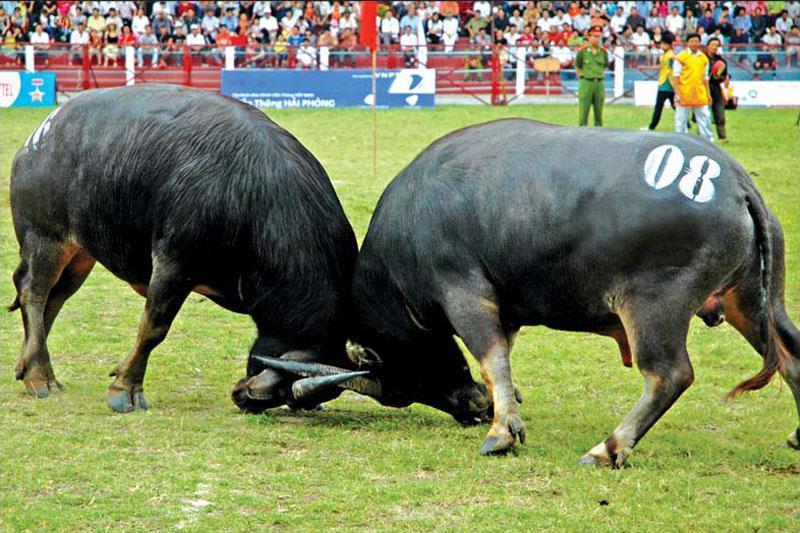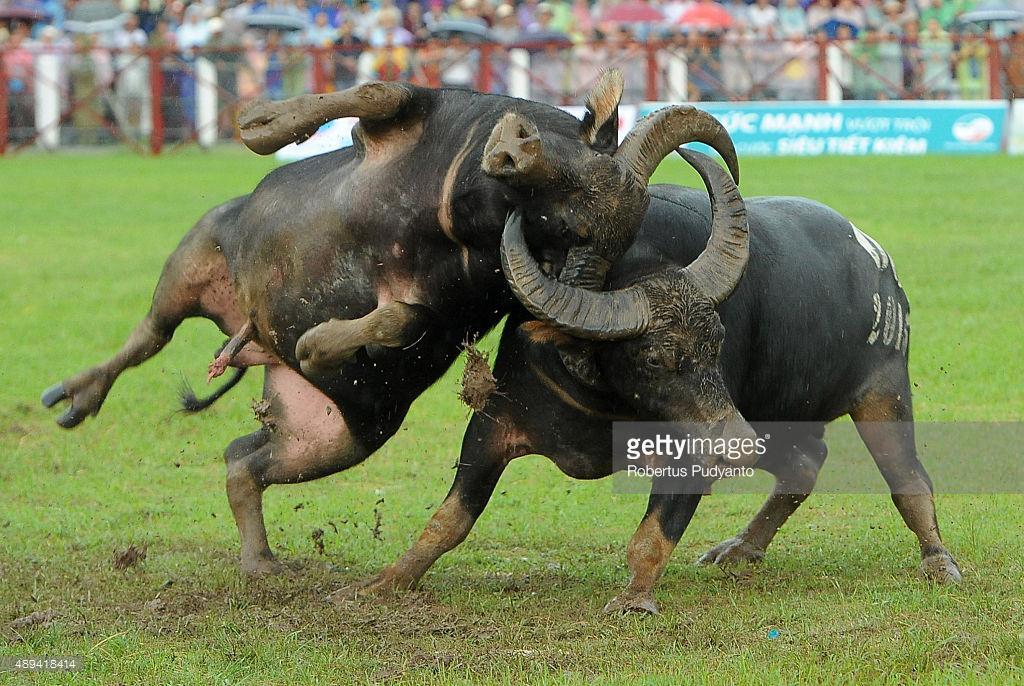The first image is the image on the left, the second image is the image on the right. For the images shown, is this caption "In the left image, both water buffalo have all four feet on the ground and their horns are locked." true? Answer yes or no. Yes. The first image is the image on the left, the second image is the image on the right. Considering the images on both sides, is "At least one bison's head is touching the ground." valid? Answer yes or no. Yes. 